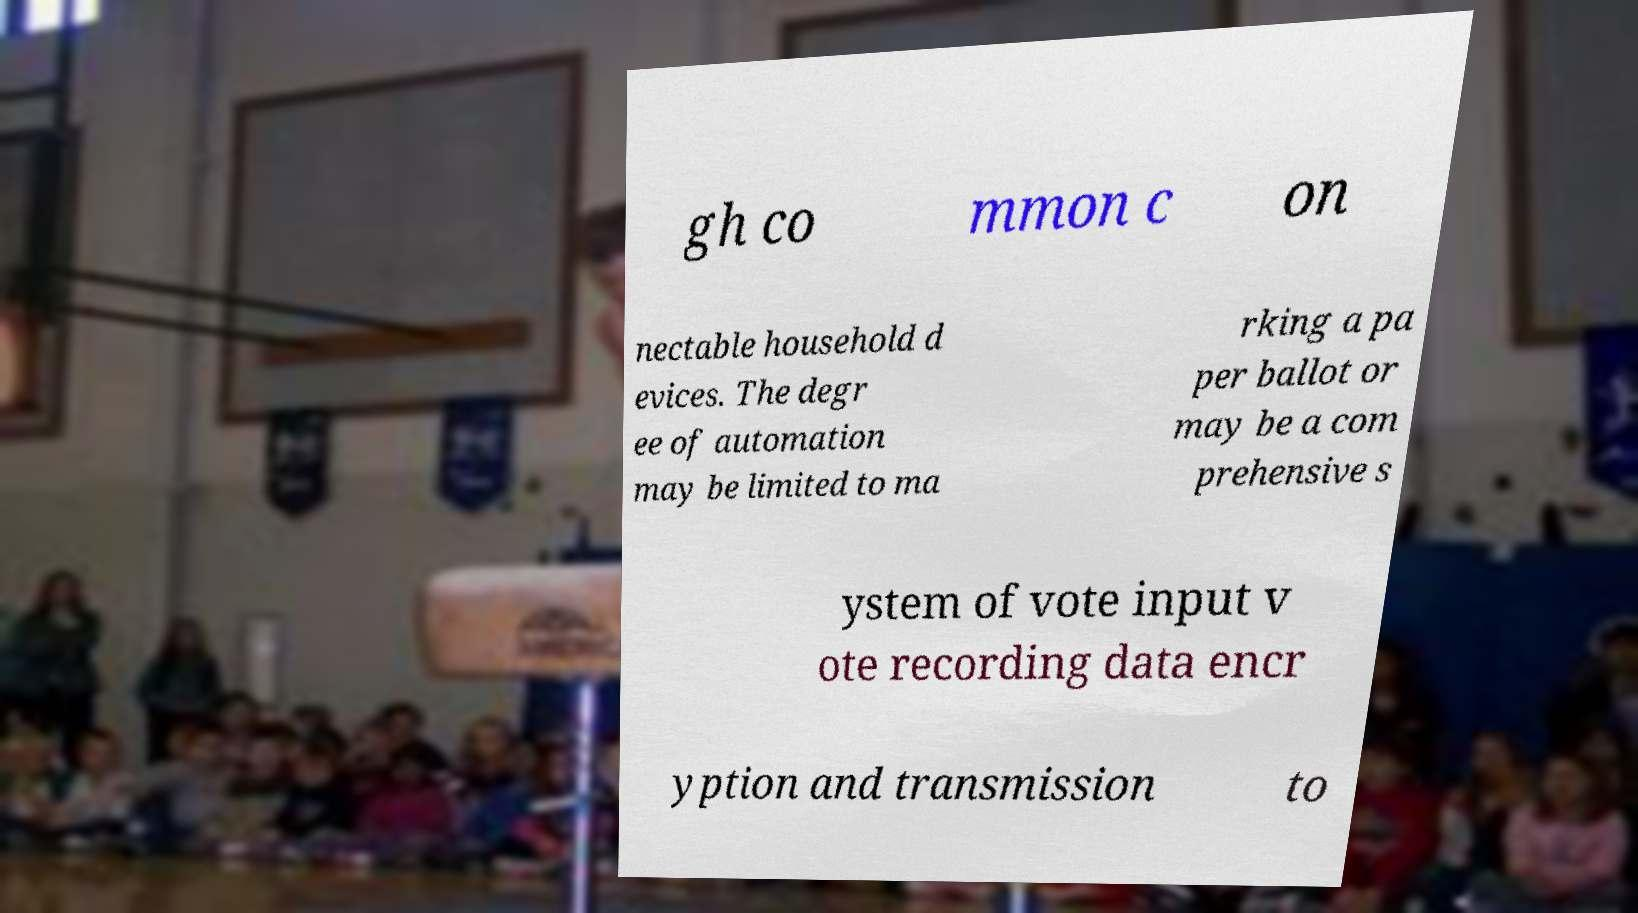I need the written content from this picture converted into text. Can you do that? gh co mmon c on nectable household d evices. The degr ee of automation may be limited to ma rking a pa per ballot or may be a com prehensive s ystem of vote input v ote recording data encr yption and transmission to 